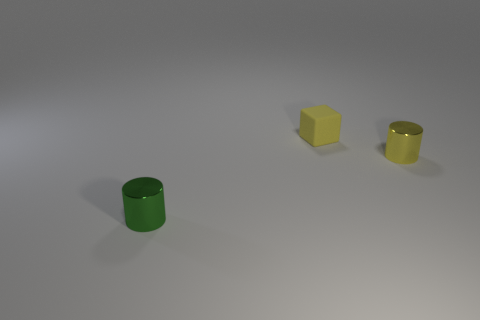Are the small cylinder in front of the small yellow metallic thing and the small thing to the right of the yellow rubber thing made of the same material?
Your answer should be compact. Yes. There is a cylinder to the left of the small yellow cube; what size is it?
Provide a short and direct response. Small. What is the material of the other object that is the same shape as the yellow metal object?
Give a very brief answer. Metal. Are there any other things that are the same size as the yellow cylinder?
Provide a short and direct response. Yes. The thing that is left of the small block has what shape?
Ensure brevity in your answer.  Cylinder. What number of other objects have the same shape as the small green shiny object?
Provide a short and direct response. 1. Is the number of shiny cylinders right of the small yellow metallic object the same as the number of metallic cylinders that are to the right of the tiny green metal object?
Offer a very short reply. No. Is there a large brown cylinder made of the same material as the tiny block?
Offer a very short reply. No. Is the material of the small yellow cylinder the same as the small green object?
Provide a short and direct response. Yes. What number of green things are either small rubber things or tiny metallic cylinders?
Make the answer very short. 1. 